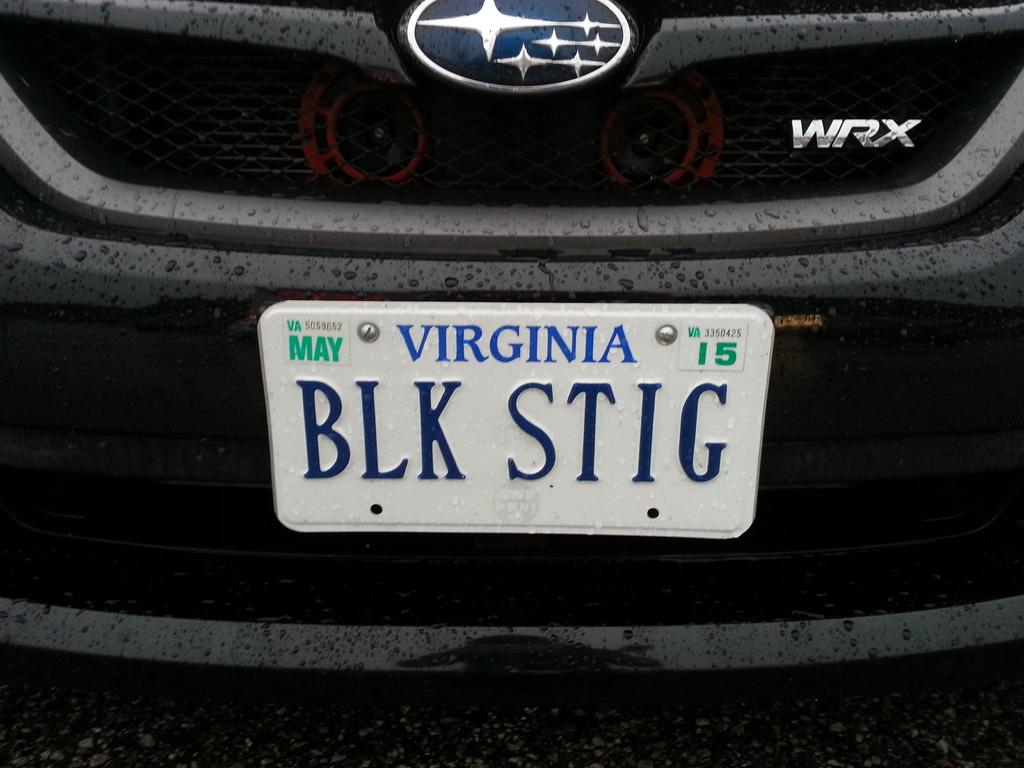What model of car is this?
Your response must be concise. Wrx. What state is the license plate from>?
Your answer should be very brief. Virginia. 